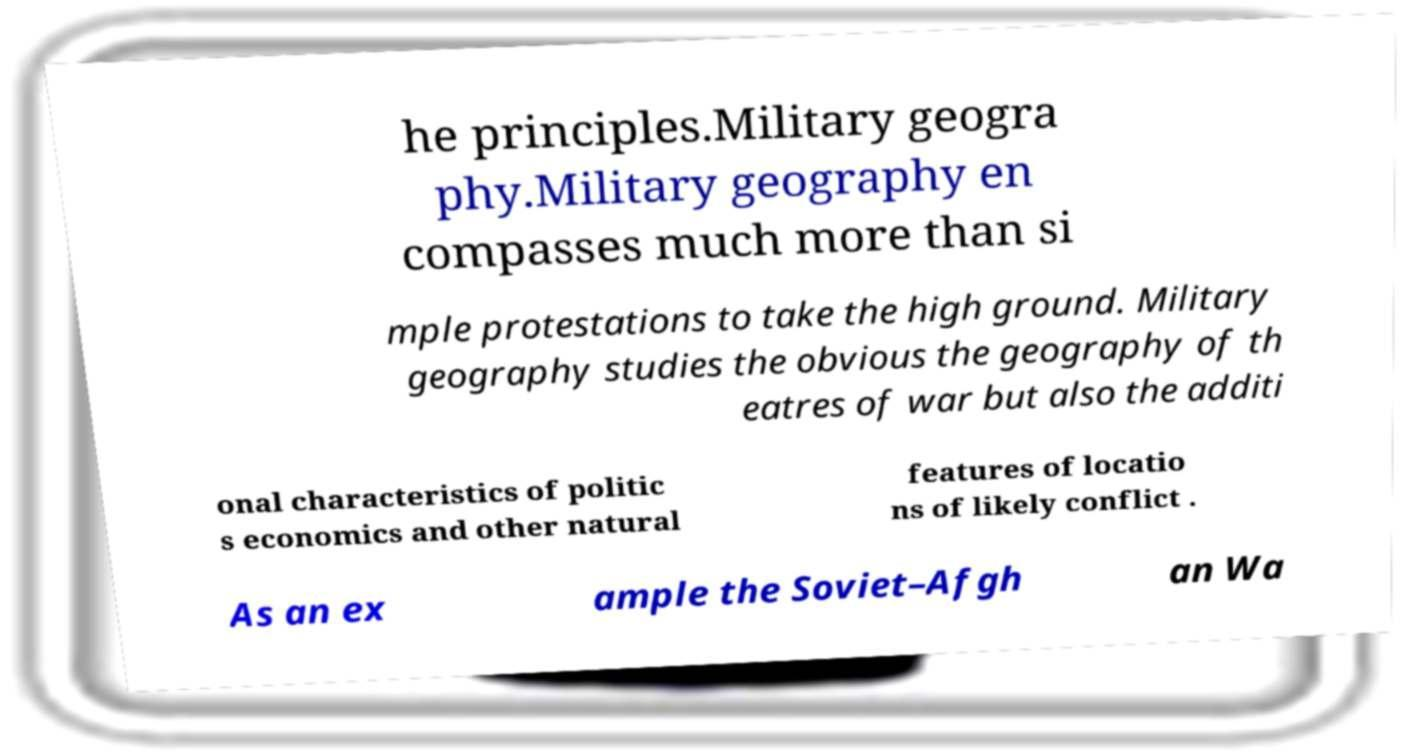Can you read and provide the text displayed in the image?This photo seems to have some interesting text. Can you extract and type it out for me? he principles.Military geogra phy.Military geography en compasses much more than si mple protestations to take the high ground. Military geography studies the obvious the geography of th eatres of war but also the additi onal characteristics of politic s economics and other natural features of locatio ns of likely conflict . As an ex ample the Soviet–Afgh an Wa 